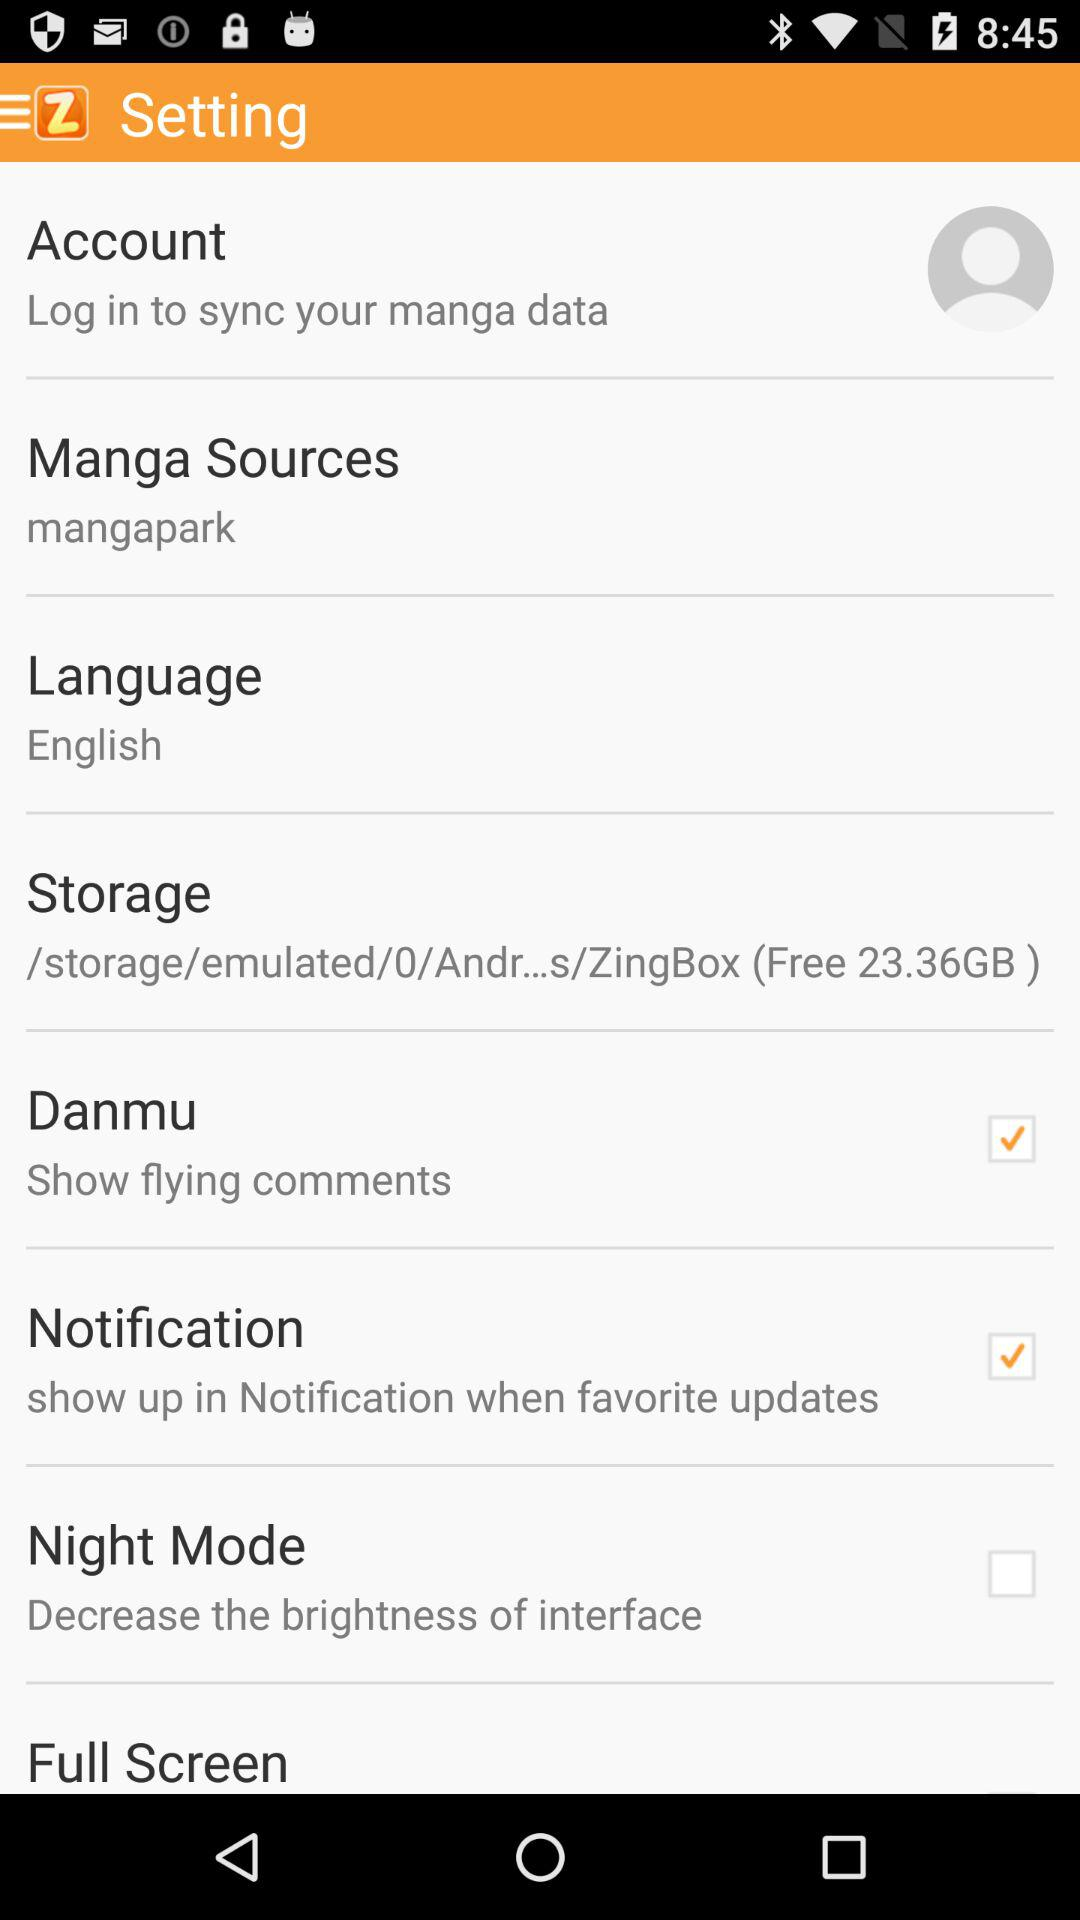How many items are in the settings menu?
Answer the question using a single word or phrase. 8 